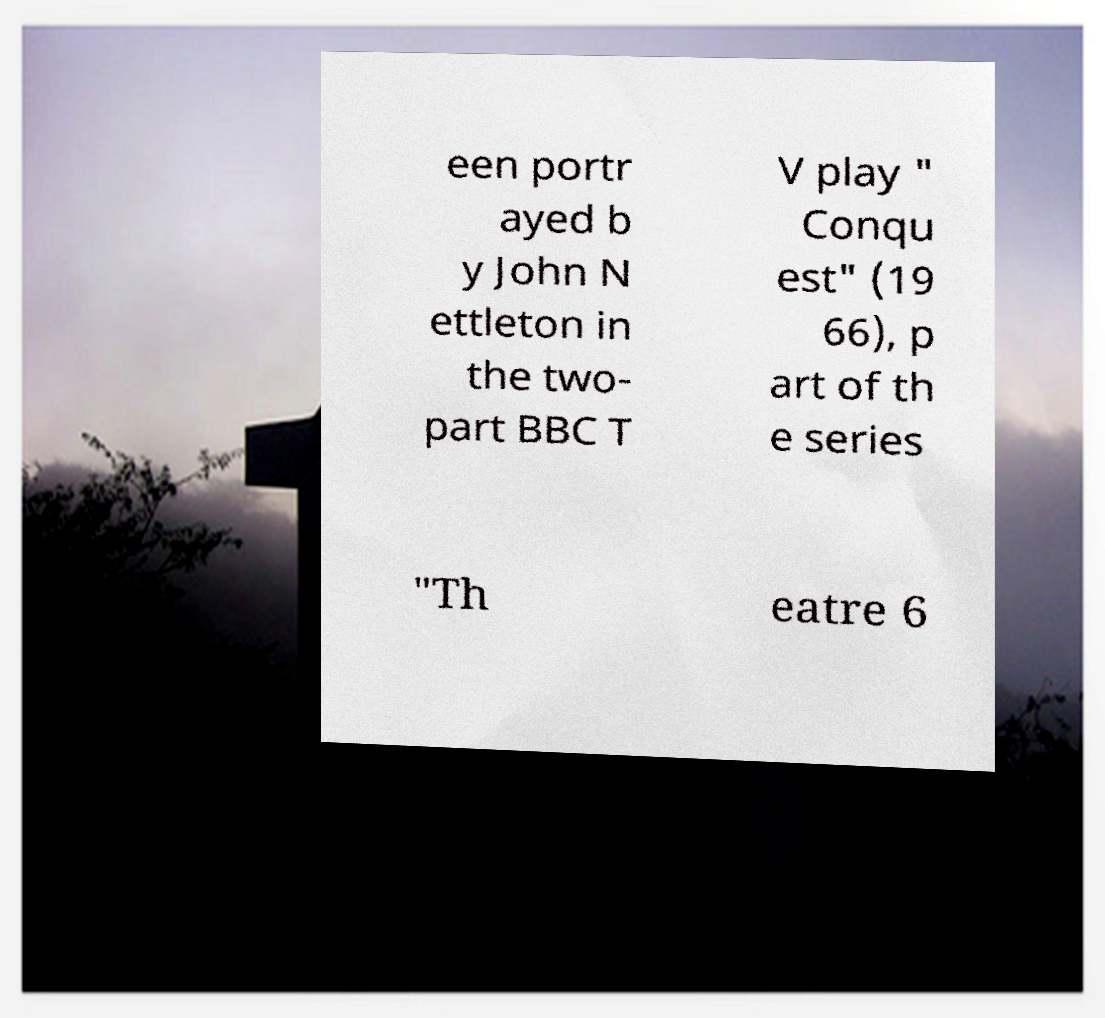Can you accurately transcribe the text from the provided image for me? een portr ayed b y John N ettleton in the two- part BBC T V play " Conqu est" (19 66), p art of th e series "Th eatre 6 